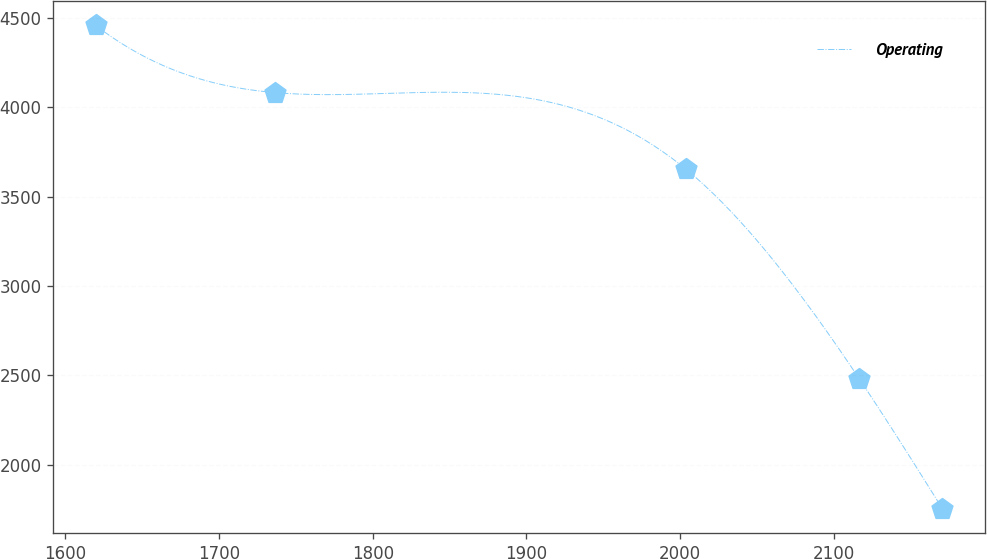Convert chart. <chart><loc_0><loc_0><loc_500><loc_500><line_chart><ecel><fcel>Operating<nl><fcel>1619.65<fcel>4456.64<nl><fcel>1736.57<fcel>4080.81<nl><fcel>2003.71<fcel>3653.38<nl><fcel>2116.58<fcel>2481.13<nl><fcel>2170.72<fcel>1754.23<nl></chart> 